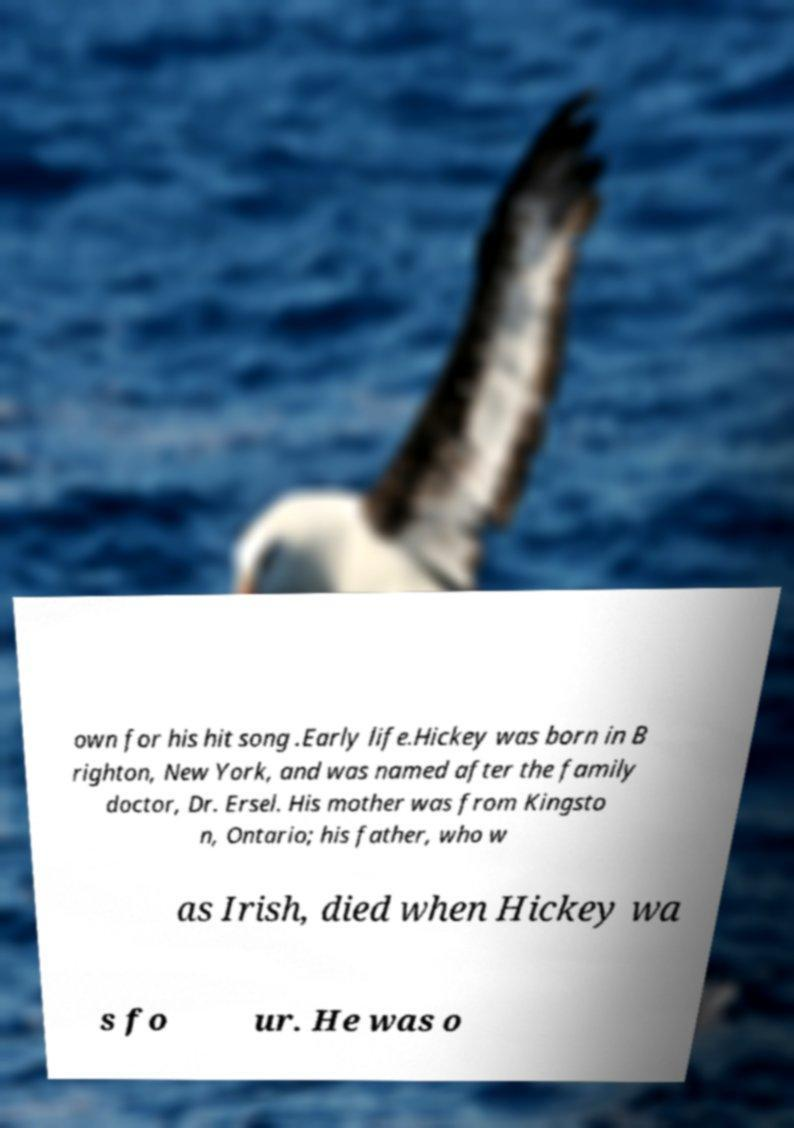Can you read and provide the text displayed in the image?This photo seems to have some interesting text. Can you extract and type it out for me? own for his hit song .Early life.Hickey was born in B righton, New York, and was named after the family doctor, Dr. Ersel. His mother was from Kingsto n, Ontario; his father, who w as Irish, died when Hickey wa s fo ur. He was o 